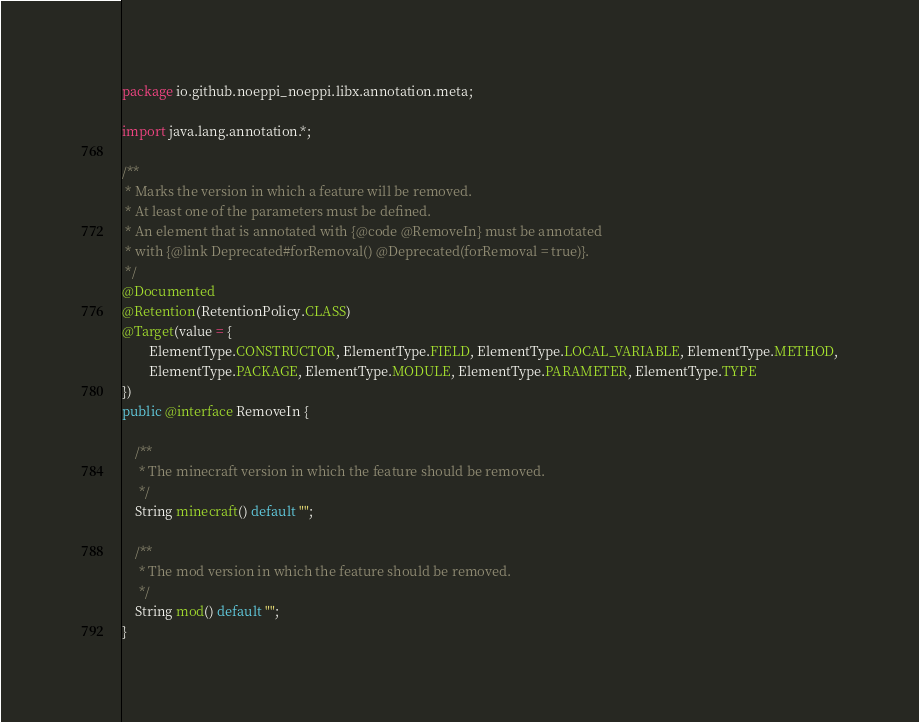<code> <loc_0><loc_0><loc_500><loc_500><_Java_>package io.github.noeppi_noeppi.libx.annotation.meta;

import java.lang.annotation.*;

/**
 * Marks the version in which a feature will be removed.
 * At least one of the parameters must be defined.
 * An element that is annotated with {@code @RemoveIn} must be annotated
 * with {@link Deprecated#forRemoval() @Deprecated(forRemoval = true)}.
 */
@Documented
@Retention(RetentionPolicy.CLASS)
@Target(value = {
        ElementType.CONSTRUCTOR, ElementType.FIELD, ElementType.LOCAL_VARIABLE, ElementType.METHOD,
        ElementType.PACKAGE, ElementType.MODULE, ElementType.PARAMETER, ElementType.TYPE
})
public @interface RemoveIn {

    /**
     * The minecraft version in which the feature should be removed.
     */
    String minecraft() default "";
    
    /**
     * The mod version in which the feature should be removed.
     */
    String mod() default "";
}
</code> 